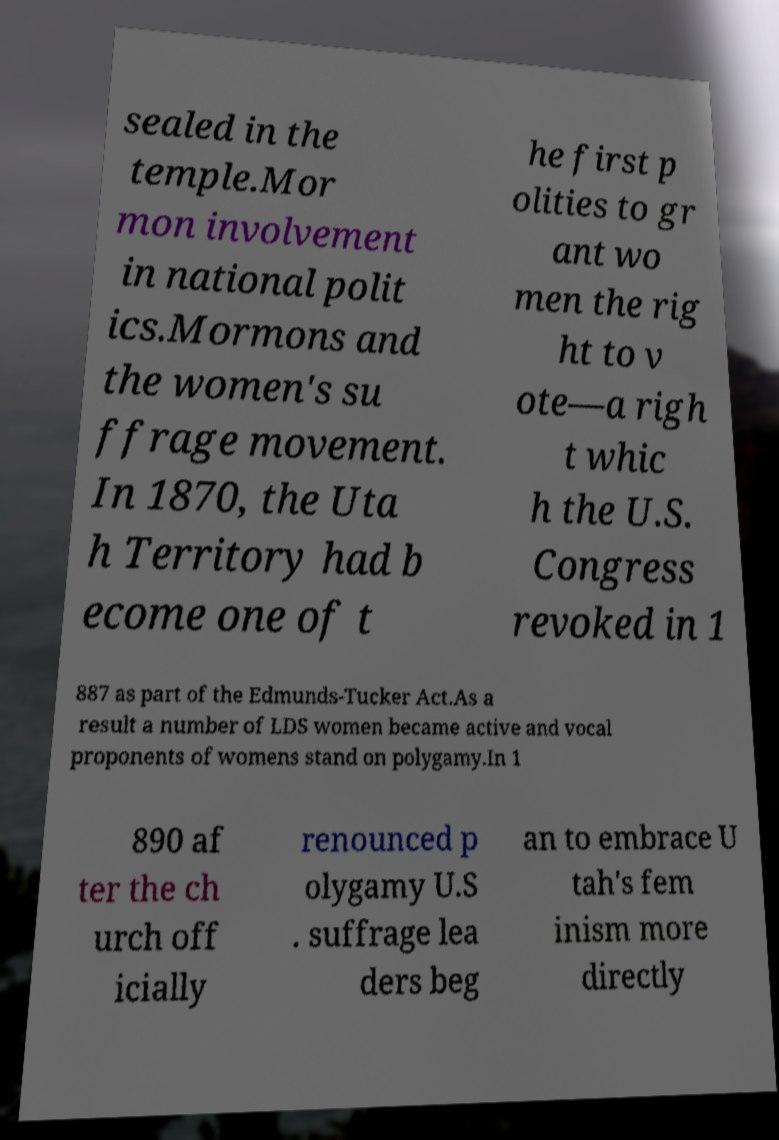What messages or text are displayed in this image? I need them in a readable, typed format. sealed in the temple.Mor mon involvement in national polit ics.Mormons and the women's su ffrage movement. In 1870, the Uta h Territory had b ecome one of t he first p olities to gr ant wo men the rig ht to v ote—a righ t whic h the U.S. Congress revoked in 1 887 as part of the Edmunds-Tucker Act.As a result a number of LDS women became active and vocal proponents of womens stand on polygamy.In 1 890 af ter the ch urch off icially renounced p olygamy U.S . suffrage lea ders beg an to embrace U tah's fem inism more directly 